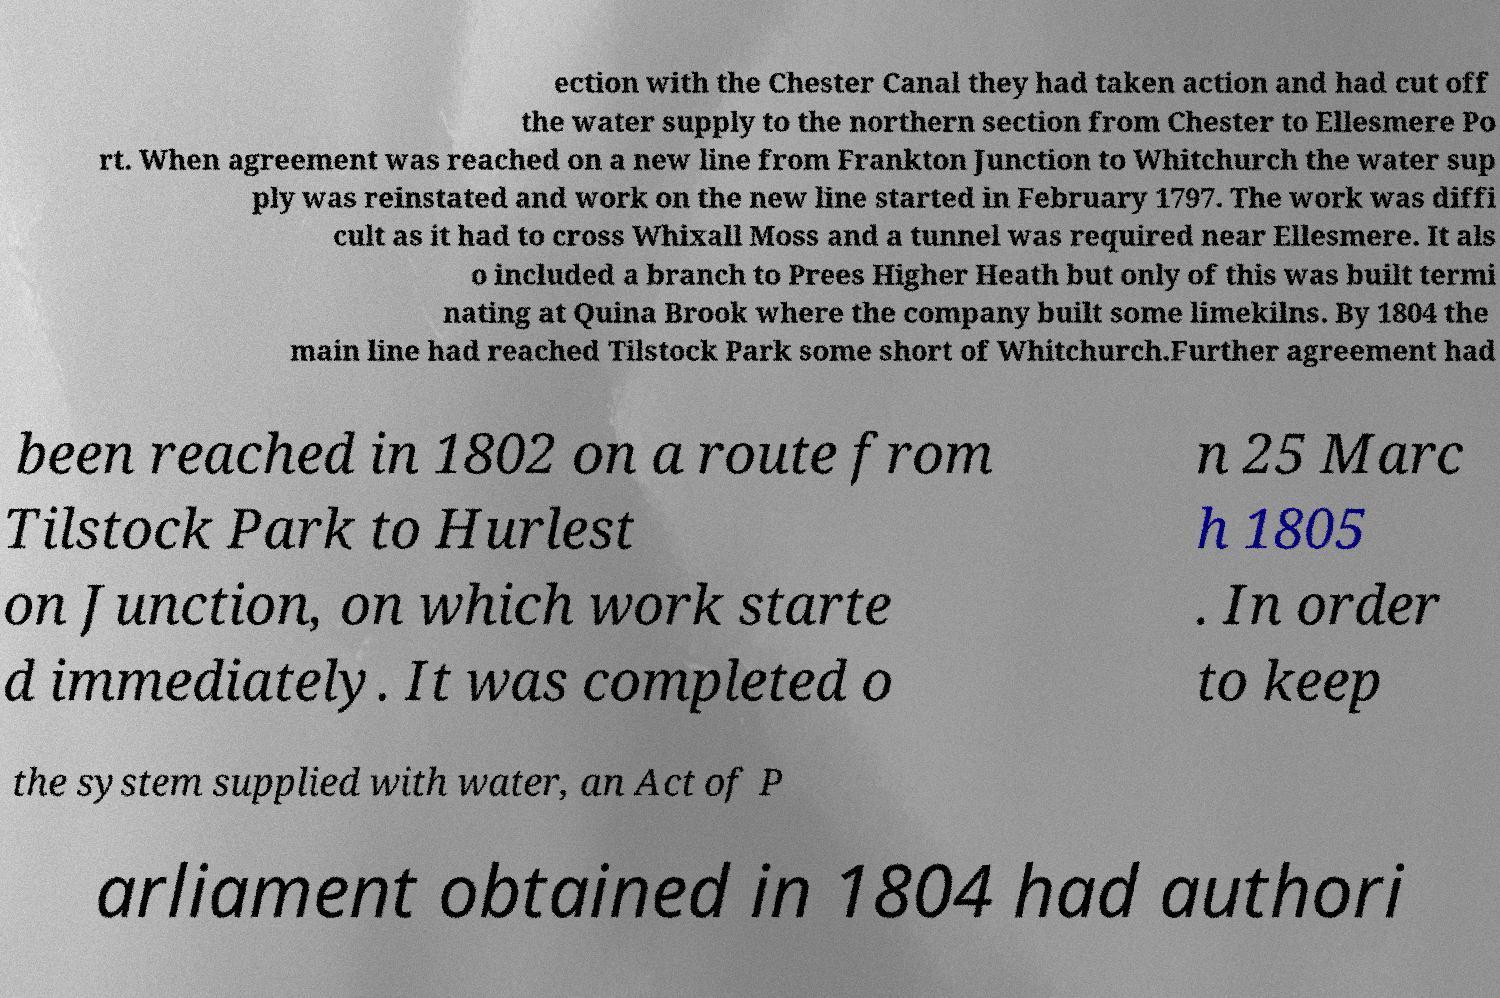Can you accurately transcribe the text from the provided image for me? ection with the Chester Canal they had taken action and had cut off the water supply to the northern section from Chester to Ellesmere Po rt. When agreement was reached on a new line from Frankton Junction to Whitchurch the water sup ply was reinstated and work on the new line started in February 1797. The work was diffi cult as it had to cross Whixall Moss and a tunnel was required near Ellesmere. It als o included a branch to Prees Higher Heath but only of this was built termi nating at Quina Brook where the company built some limekilns. By 1804 the main line had reached Tilstock Park some short of Whitchurch.Further agreement had been reached in 1802 on a route from Tilstock Park to Hurlest on Junction, on which work starte d immediately. It was completed o n 25 Marc h 1805 . In order to keep the system supplied with water, an Act of P arliament obtained in 1804 had authori 